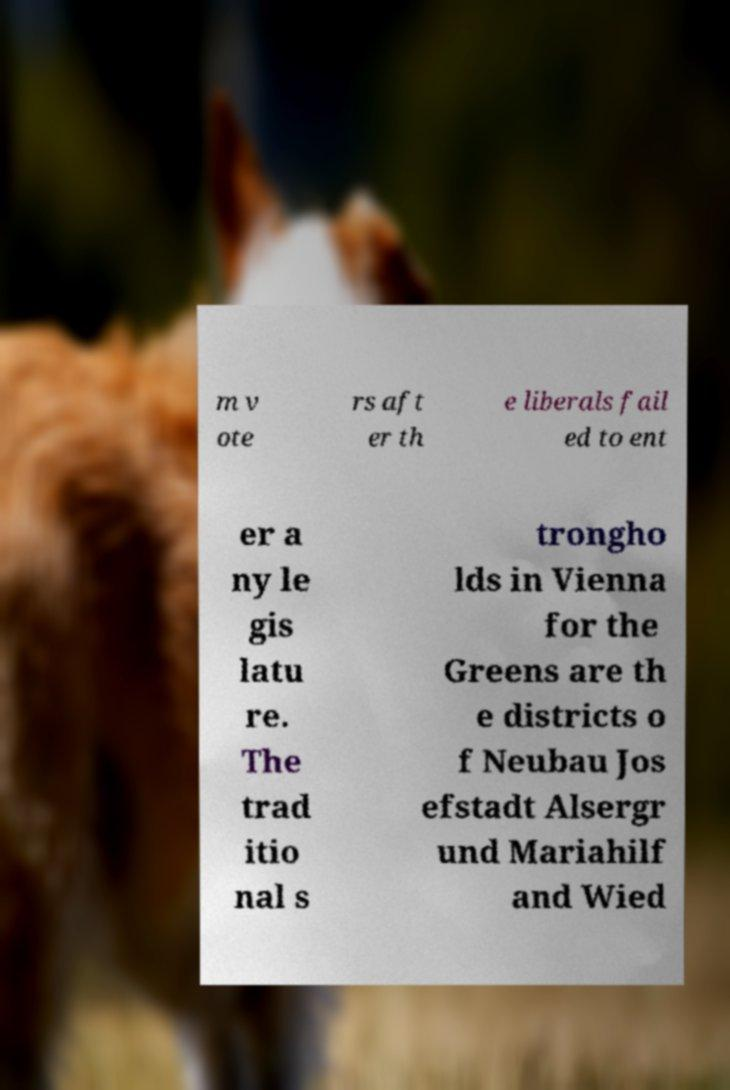I need the written content from this picture converted into text. Can you do that? m v ote rs aft er th e liberals fail ed to ent er a ny le gis latu re. The trad itio nal s trongho lds in Vienna for the Greens are th e districts o f Neubau Jos efstadt Alsergr und Mariahilf and Wied 